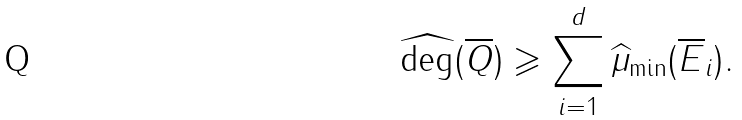Convert formula to latex. <formula><loc_0><loc_0><loc_500><loc_500>\widehat { \deg } ( \overline { Q } ) \geqslant \sum _ { i = 1 } ^ { d } \widehat { \mu } _ { \min } ( \overline { E } _ { i } ) .</formula> 